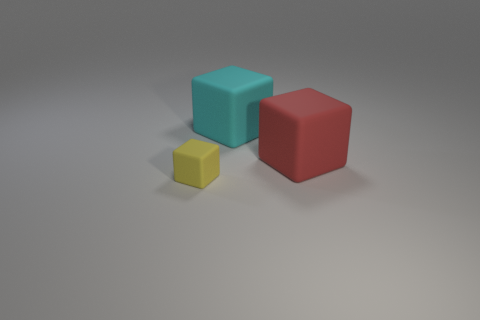Subtract all big rubber cubes. How many cubes are left? 1 Subtract 2 blocks. How many blocks are left? 1 Add 2 small matte things. How many objects exist? 5 Subtract all red cubes. How many cubes are left? 2 Add 2 red blocks. How many red blocks are left? 3 Add 2 cyan cubes. How many cyan cubes exist? 3 Subtract 0 blue balls. How many objects are left? 3 Subtract all gray blocks. Subtract all blue balls. How many blocks are left? 3 Subtract all purple balls. How many cyan cubes are left? 1 Subtract all big gray rubber cylinders. Subtract all tiny blocks. How many objects are left? 2 